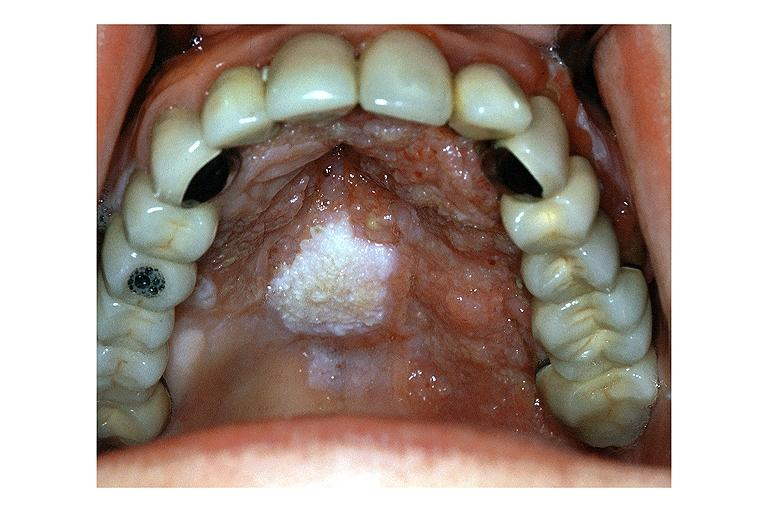does this image show verrucous carcinoma?
Answer the question using a single word or phrase. Yes 